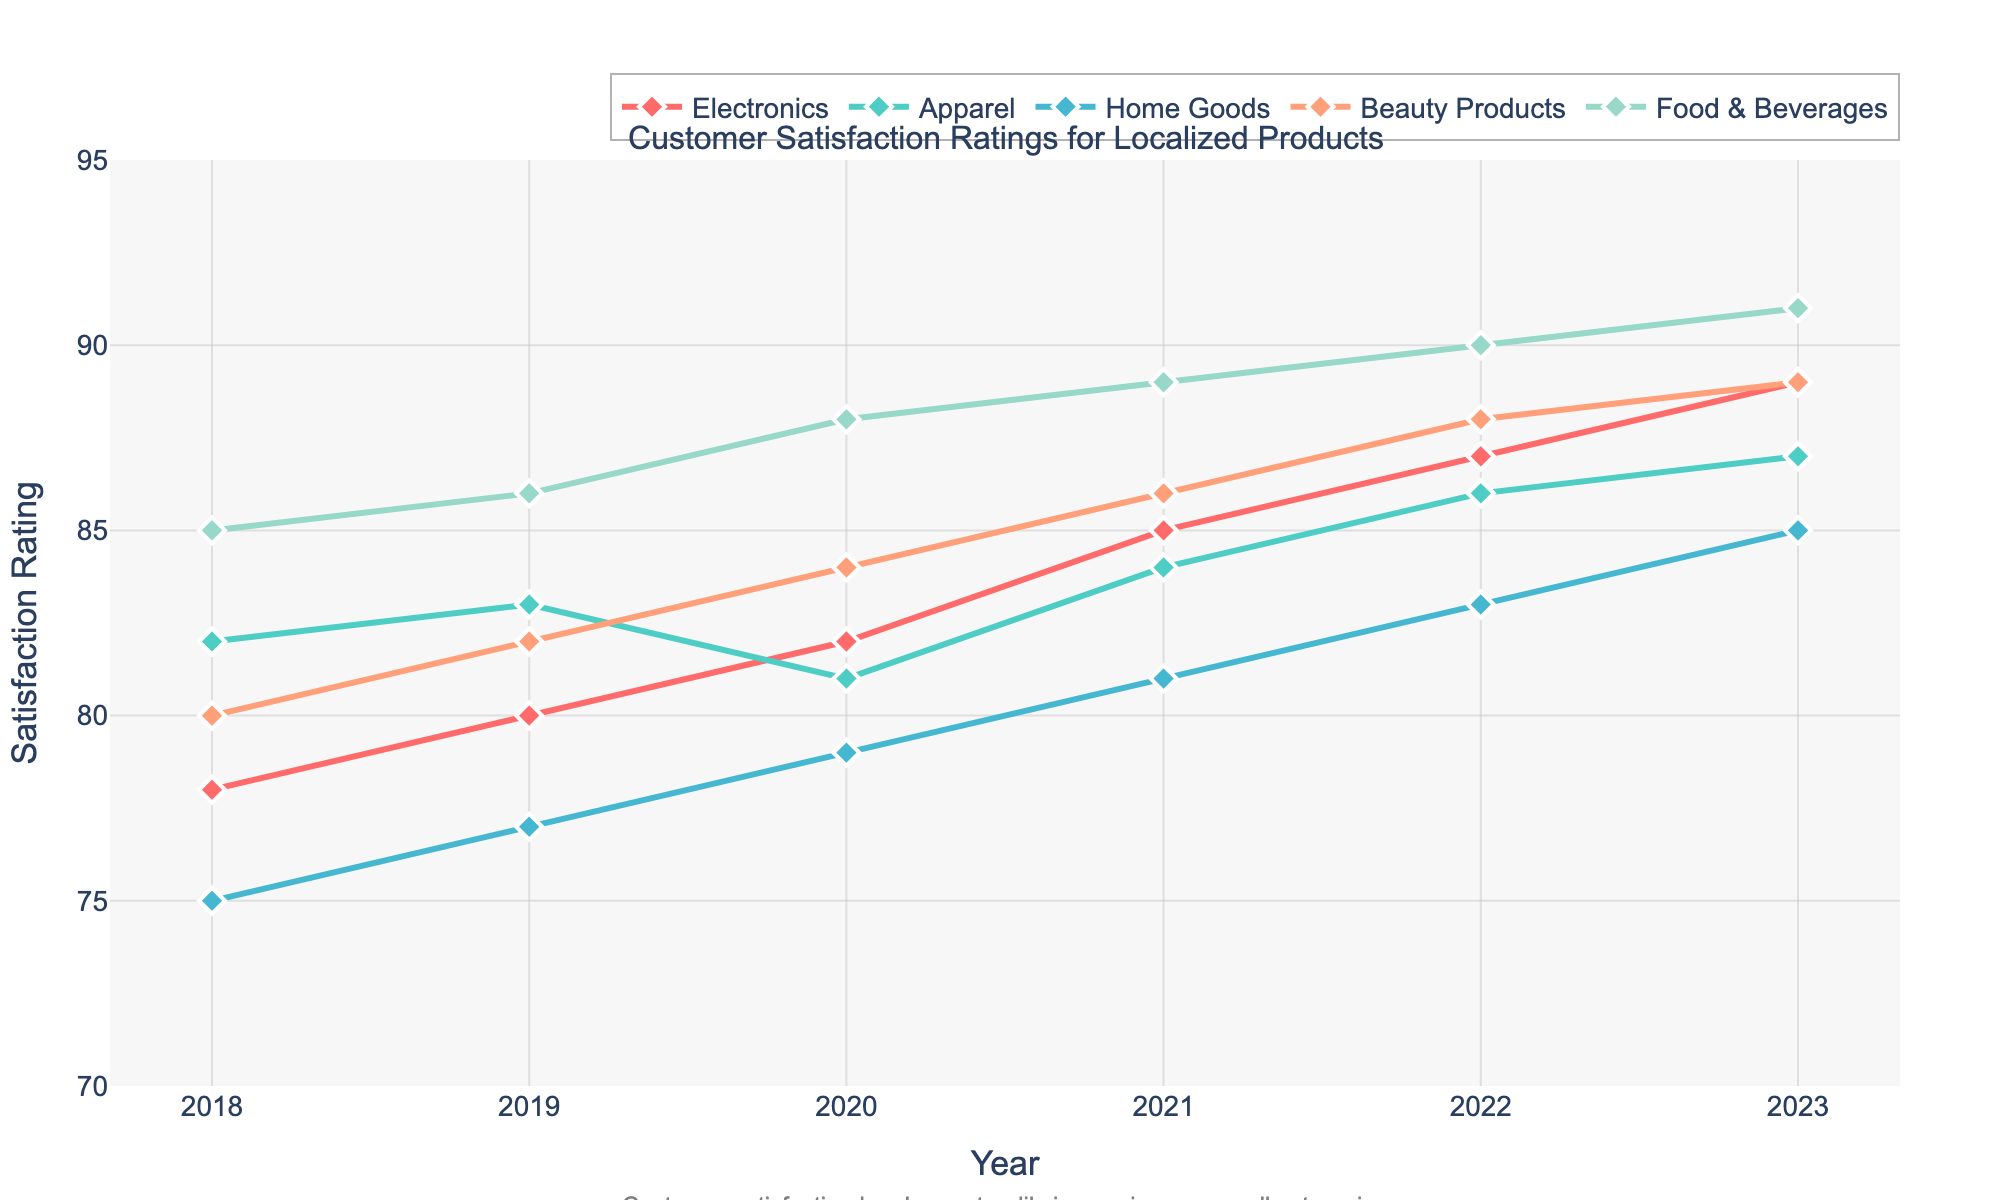What year had the highest satisfaction rating for Electronics? The highest satisfaction rating can be found by looking at the peak of the Electronics line. The line reaches its highest point in 2023.
Answer: 2023 Which product category showed the most improvement from 2018 to 2023? To determine the most improvement, calculate the difference between the 2023 and 2018 ratings for each category. The differences are as follows: Electronics: 89-78=11, Apparel: 87-82=5, Home Goods: 85-75=10, Beauty Products: 89-80=9, Food & Beverages: 91-85=6. Electronics showed the most improvement with an increase of 11 points.
Answer: Electronics How many product categories achieved a satisfaction rating of 90 or above in 2023? In 2023, check the position of the markers. Food & Beverages achieved 91, which is above 90. No other categories are at or above 90 in 2023.
Answer: 1 Between which consecutive years did Apparel show a decline in satisfaction rating? Inspect the line for Apparel and identify any downward slopes between two specific years. The Apparel rating decreases from 83 to 81 between 2019 and 2020.
Answer: 2019-2020 What is the average satisfaction rating for Beauty Products across all years? To find the average, add up all the ratings for Beauty Products and divide by the number of years. (80+82+84+86+88+89) / 6 = 84.83
Answer: 84.83 Which product category had a lower satisfaction rating than Electronics but higher than Home Goods in 2021? Look at the ratings for each category in 2021 and compare them: Electronics: 85, Apparel: 84, Home Goods: 81, Beauty Products: 86, Food & Beverages: 89. Apparel has a rating of 84, which is lower than Electronics but higher than Home Goods.
Answer: Apparel What is the overall trend observed in customer satisfaction for all categories from 2018 to 2023? Analyze the general direction of the lines for all categories from 2018 to 2023. Each line shows an upward trend, indicating increasing customer satisfaction over the years.
Answer: Increasing How does the satisfaction rating of Food & Beverages in 2020 compare to Beauty Products in 2020? Compare the ratings for Food & Beverages and Beauty Products in 2020. Food & Beverages: 88, Beauty Products: 84.
Answer: Higher In which year was the satisfaction rating for Home Goods the lowest? The lowest point on the Home Goods line indicates the lowest satisfaction rating. This occurs in 2018, where the rating is 75.
Answer: 2018 